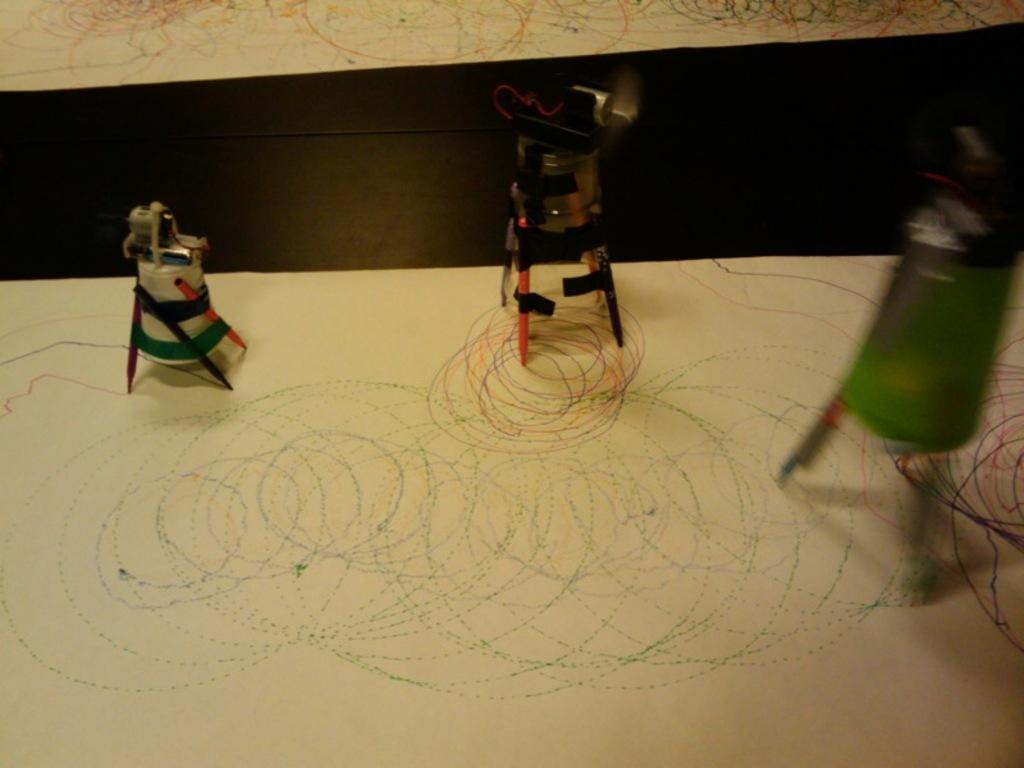Can you describe this image briefly? We can see objects with pencils and papers on the surface. 